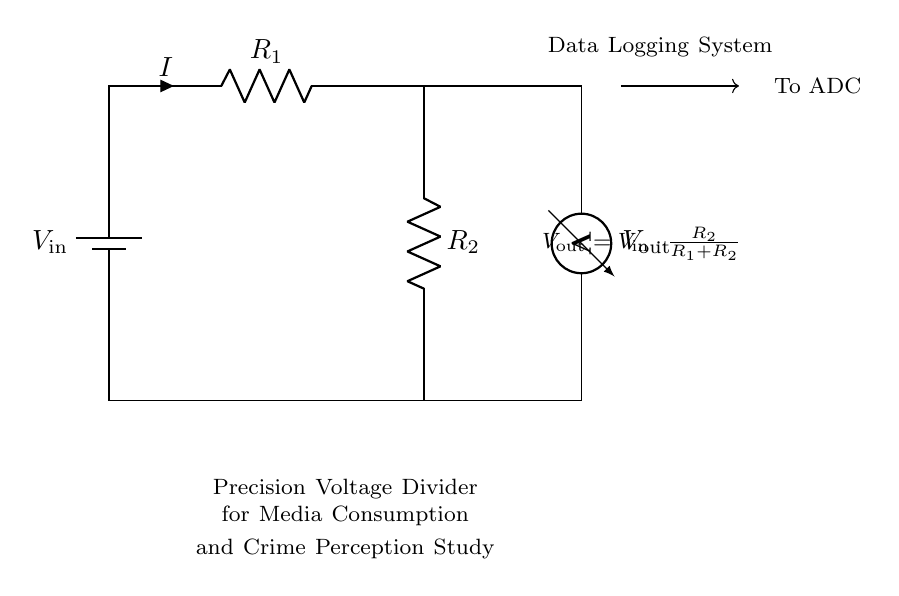What is the input voltage of the circuit? The input voltage is labeled as \( V_\text{in} \) at the battery in the diagram.
Answer: \( V_\text{in} \) What are the resistance values in the circuit? The resistances are labeled as \( R_1 \) and \( R_2 \) in the diagram, but their specific values are not provided here.
Answer: \( R_1 \) and \( R_2 \) What is the formula for the output voltage? The output voltage formula is given in the diagram as \( V_\text{out} = V_\text{in} \cdot \frac{R_2}{R_1+R_2} \), showing how the output is derived from the resistances and input voltage.
Answer: \( V_\text{in} \cdot \frac{R_2}{R_1+R_2} \) How does resistance \( R_2 \) affect the output voltage? \( R_2 \) is in the numerator of the output voltage formula, implying that as \( R_2 \) increases, \( V_\text{out} \) also increases, given constant \( V_\text{in} \) and \( R_1 \).
Answer: Increases What happens to output voltage if \( R_1 \) becomes significantly larger than \( R_2 \)? If \( R_1 \) is much larger than \( R_2 \), the output voltage \( V_\text{out} \) approaches zero, since the ratio \( \frac{R_2}{R_1 + R_2} \) becomes negligible.
Answer: Approaches zero What is the role of the voltmeter in this circuit? The voltmeter is used to measure the output voltage \( V_\text{out} \), indicating the potential difference across the second resistor \( R_2 \).
Answer: Measure output voltage 